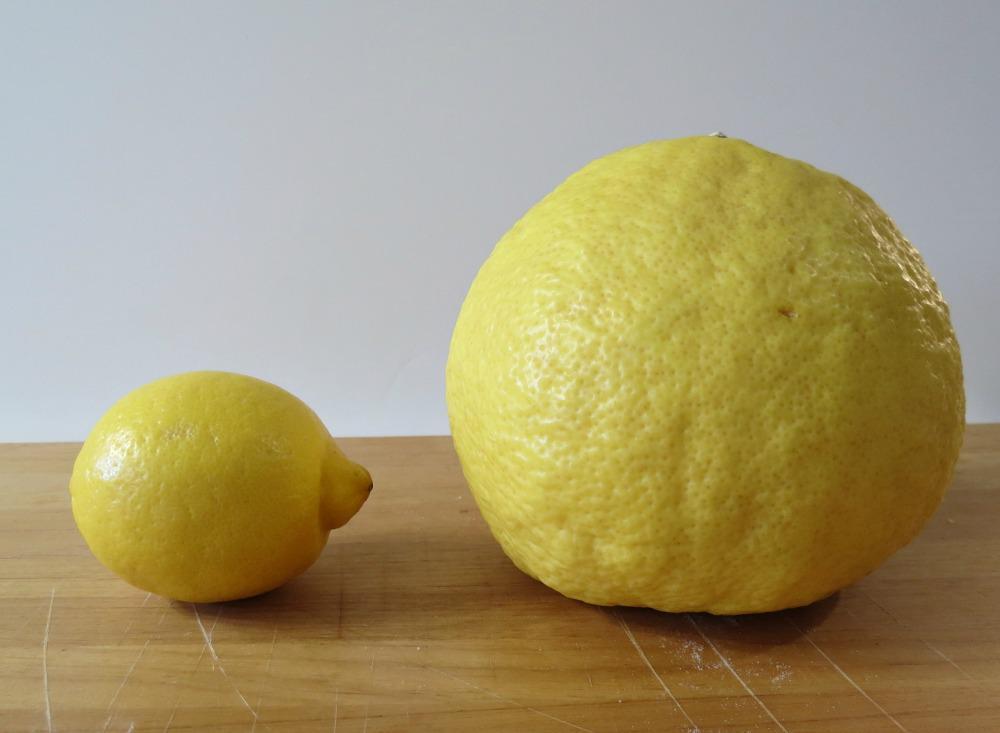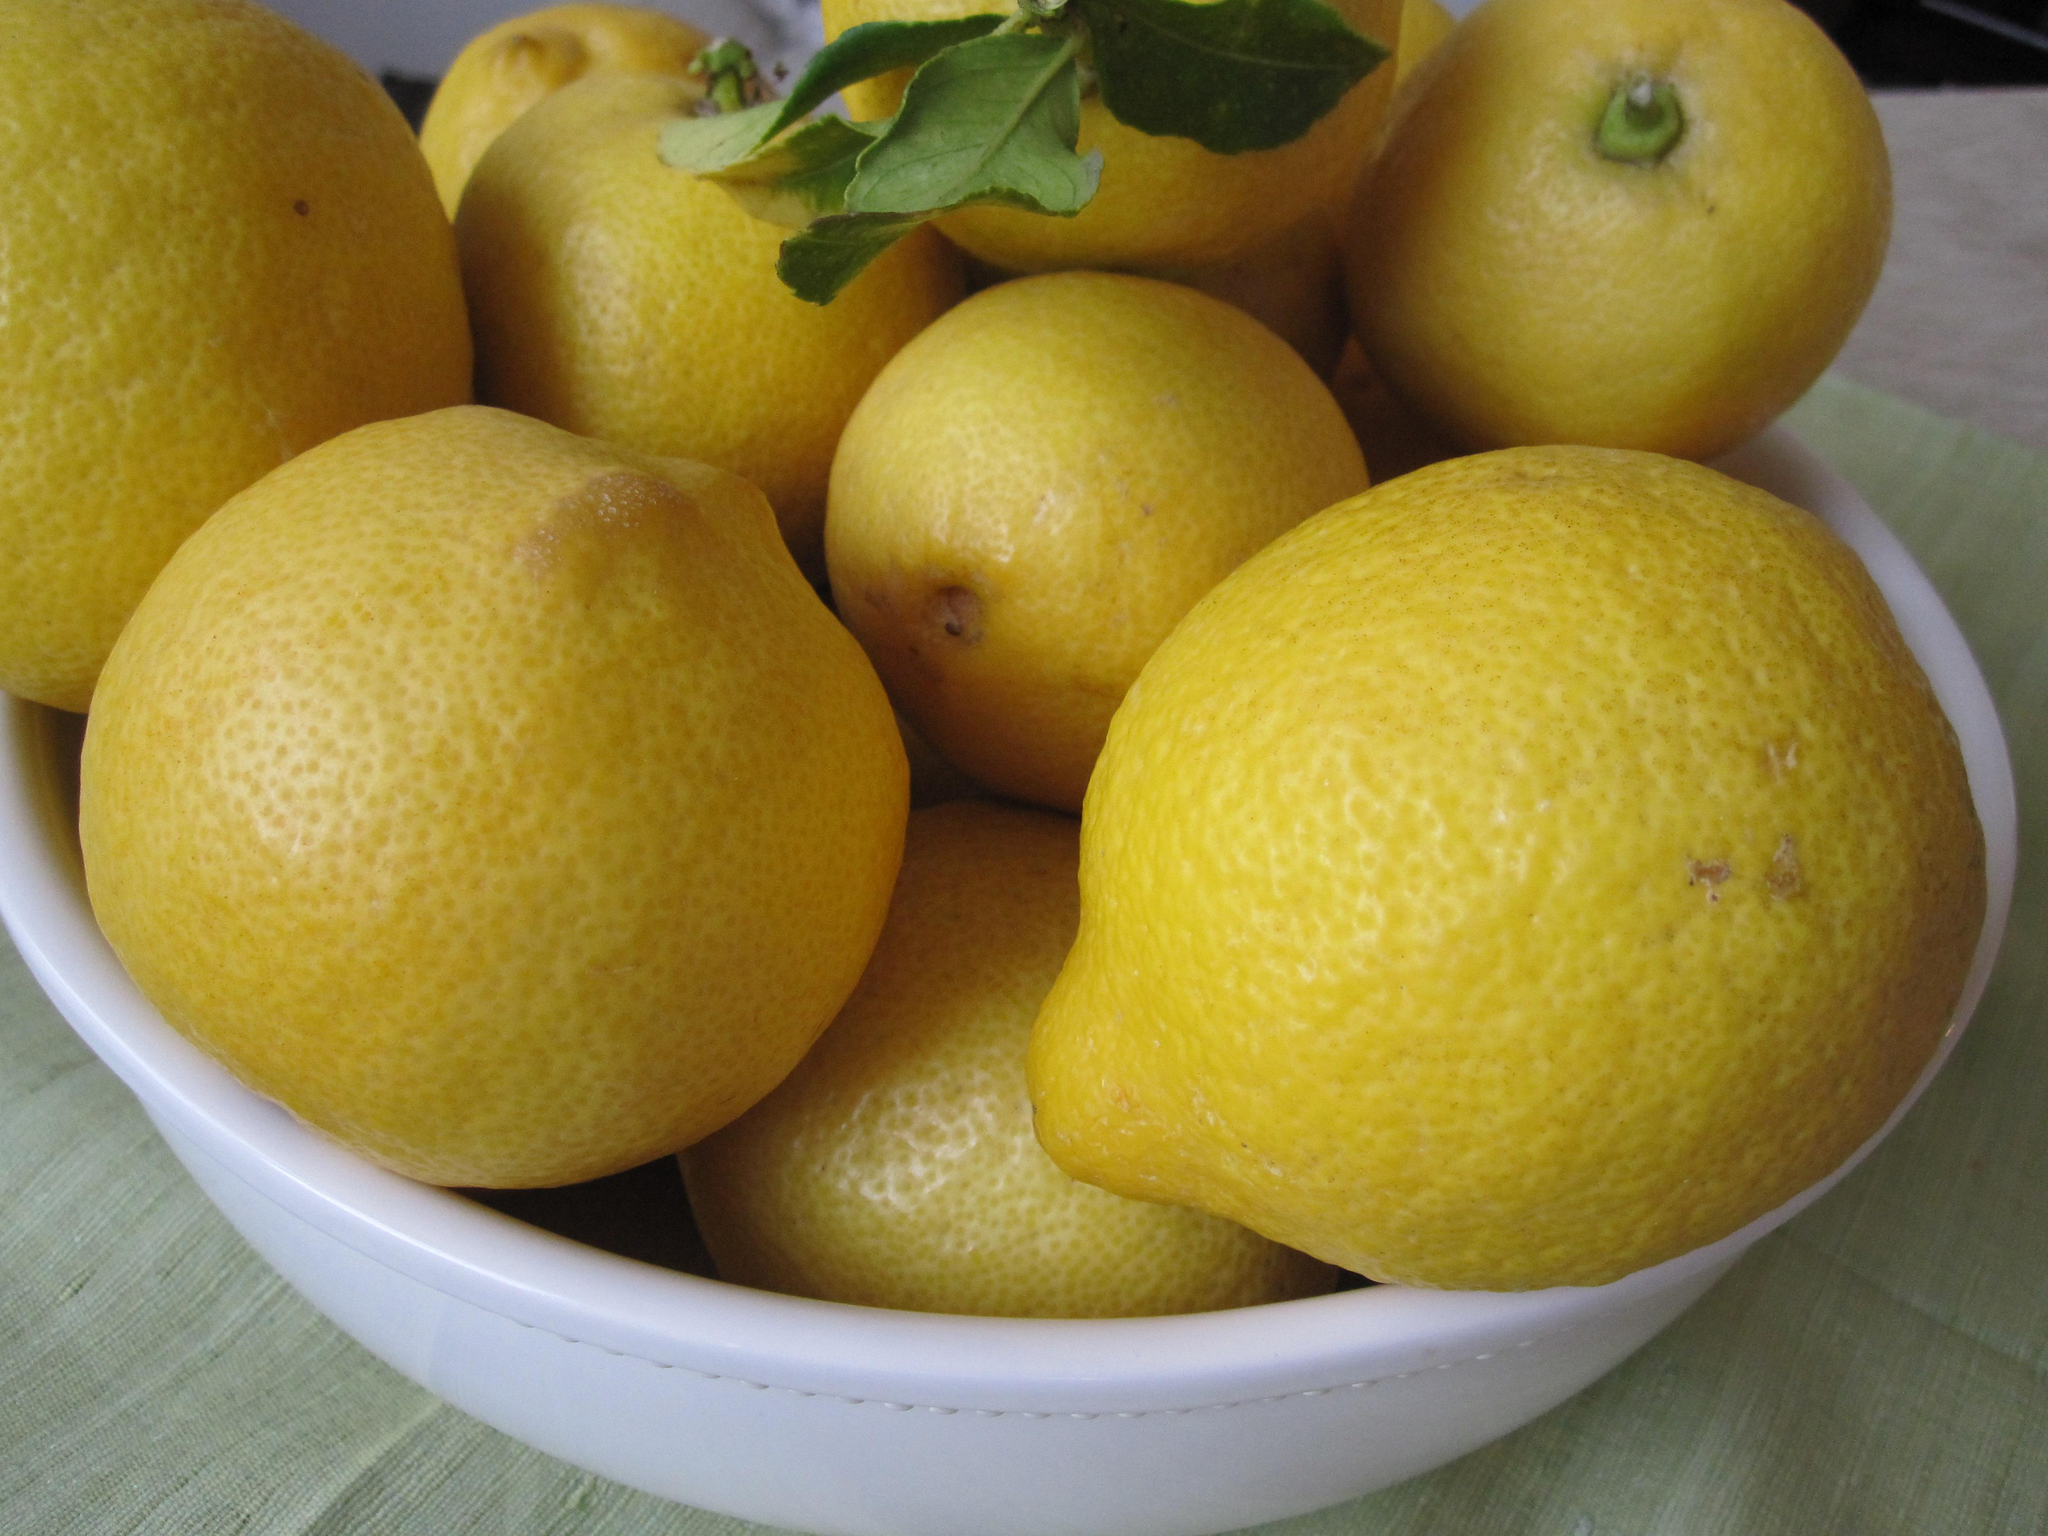The first image is the image on the left, the second image is the image on the right. Considering the images on both sides, is "The right image includes yellow fruit in a round bowl, and the left image shows a small fruit on the left of a larger fruit of the same color." valid? Answer yes or no. Yes. 